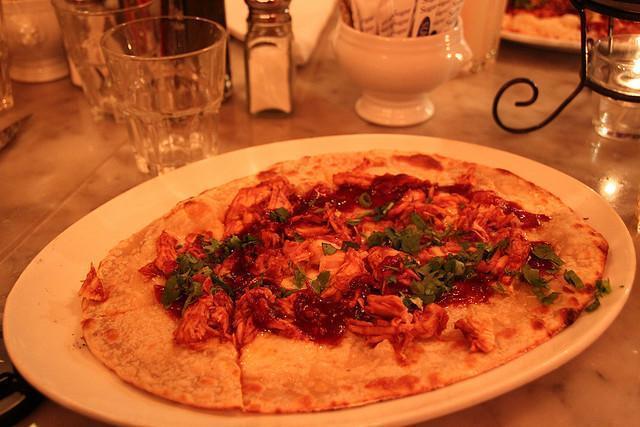How many slices are missing here?
Give a very brief answer. 0. How many cups are there?
Give a very brief answer. 4. How many pizzas can be seen?
Give a very brief answer. 2. 